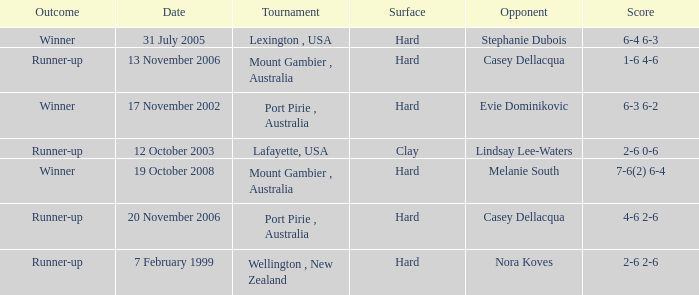Which Opponent is on 17 november 2002? Evie Dominikovic. 